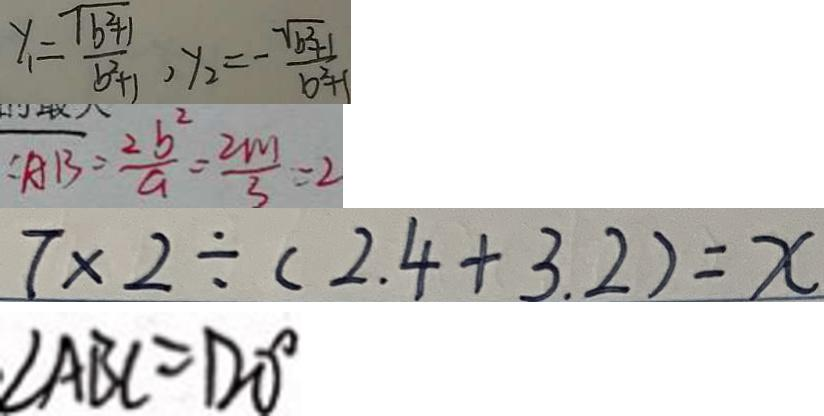Convert formula to latex. <formula><loc_0><loc_0><loc_500><loc_500>y _ { 1 } = \frac { \sqrt { b ^ { 2 } + 1 } } { b ^ { 2 } + 1 } , y _ { 2 } = - \frac { \sqrt { b ^ { 2 } + 1 } } { b ^ { 2 } + 1 } 
 : A B = \frac { 2 b ^ { 2 } } { a } = \frac { 2 m } { 3 } = 2 
 7 \times 2 \div ( 2 . 4 + 3 . 2 ) = x 
 \angle A B C = 1 2 0 ^ { \circ }</formula> 